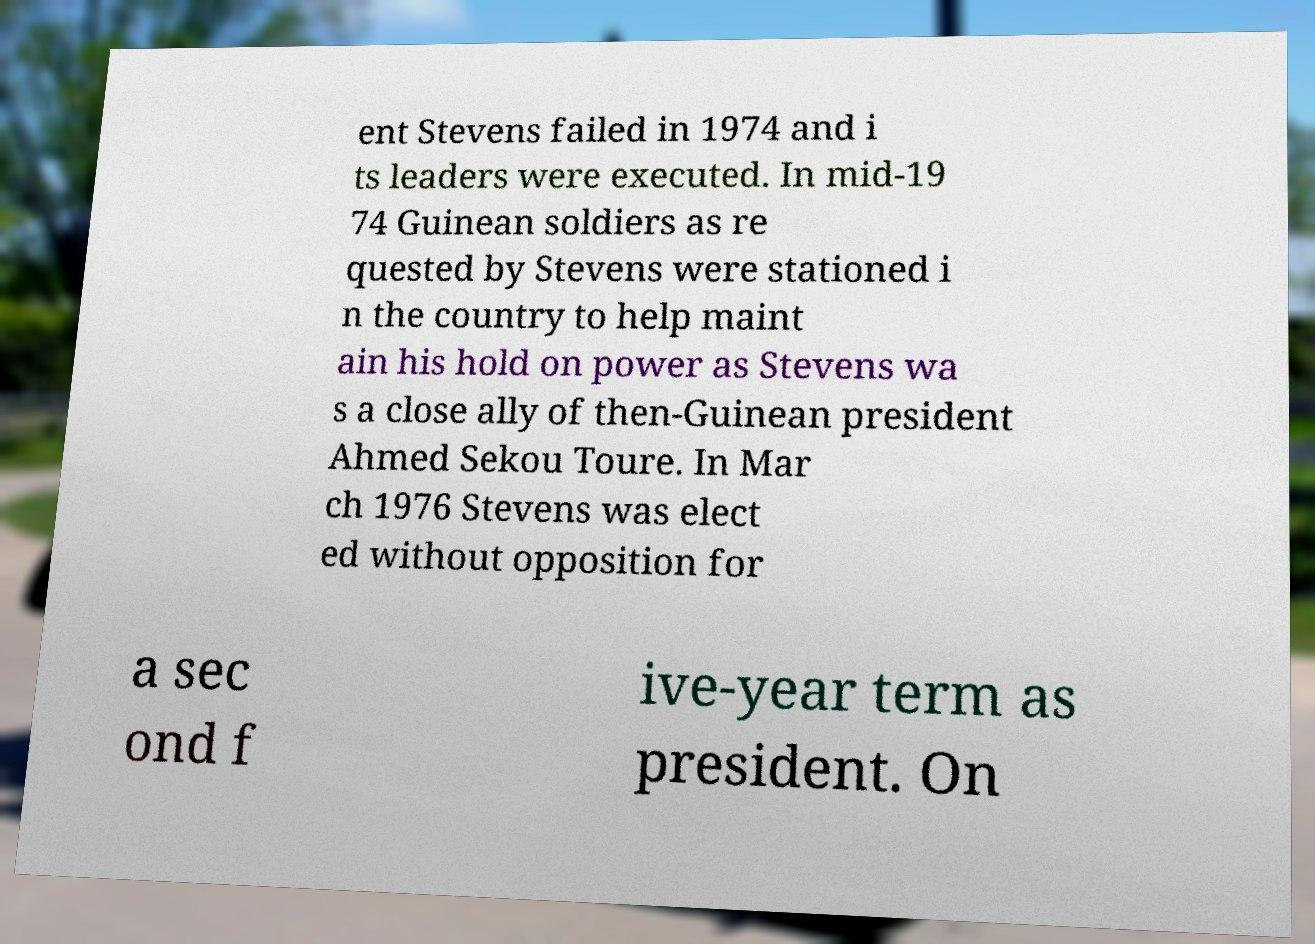There's text embedded in this image that I need extracted. Can you transcribe it verbatim? ent Stevens failed in 1974 and i ts leaders were executed. In mid-19 74 Guinean soldiers as re quested by Stevens were stationed i n the country to help maint ain his hold on power as Stevens wa s a close ally of then-Guinean president Ahmed Sekou Toure. In Mar ch 1976 Stevens was elect ed without opposition for a sec ond f ive-year term as president. On 